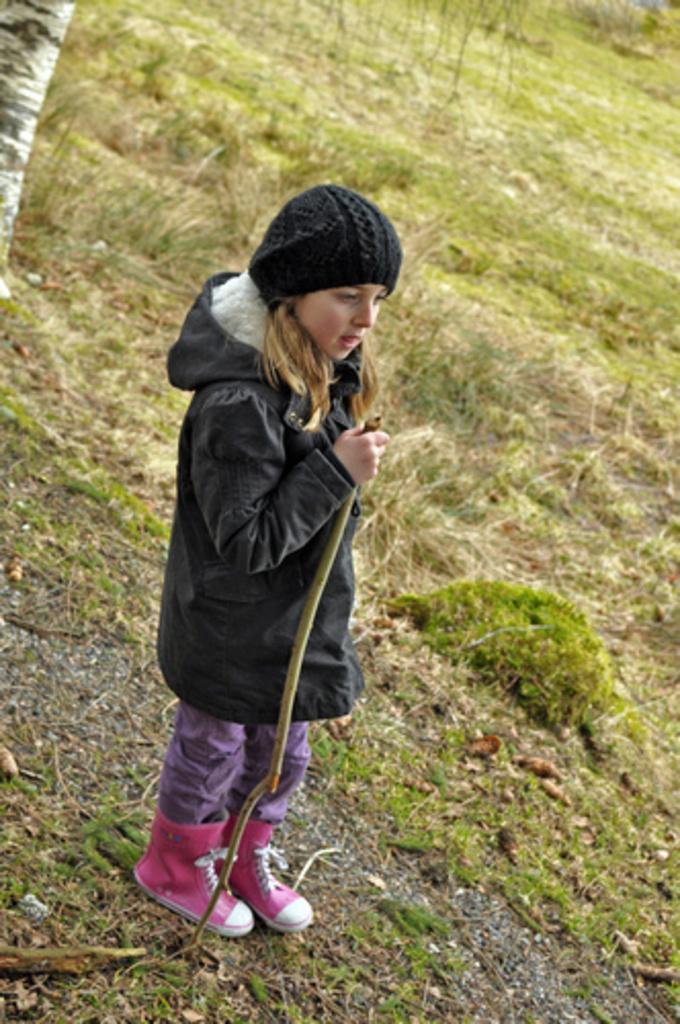In one or two sentences, can you explain what this image depicts? In this picture we can see a girl wore a cap, jacket, shoes, holding a stick with her hand and standing on the ground and in the background we can see the grass. 